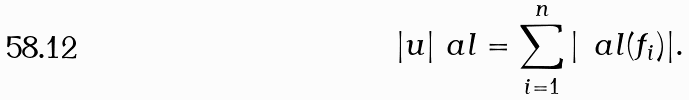<formula> <loc_0><loc_0><loc_500><loc_500>| u | _ { \ } a l = \sum _ { i = 1 } ^ { n } | \, \ a l ( f _ { i } ) | .</formula> 